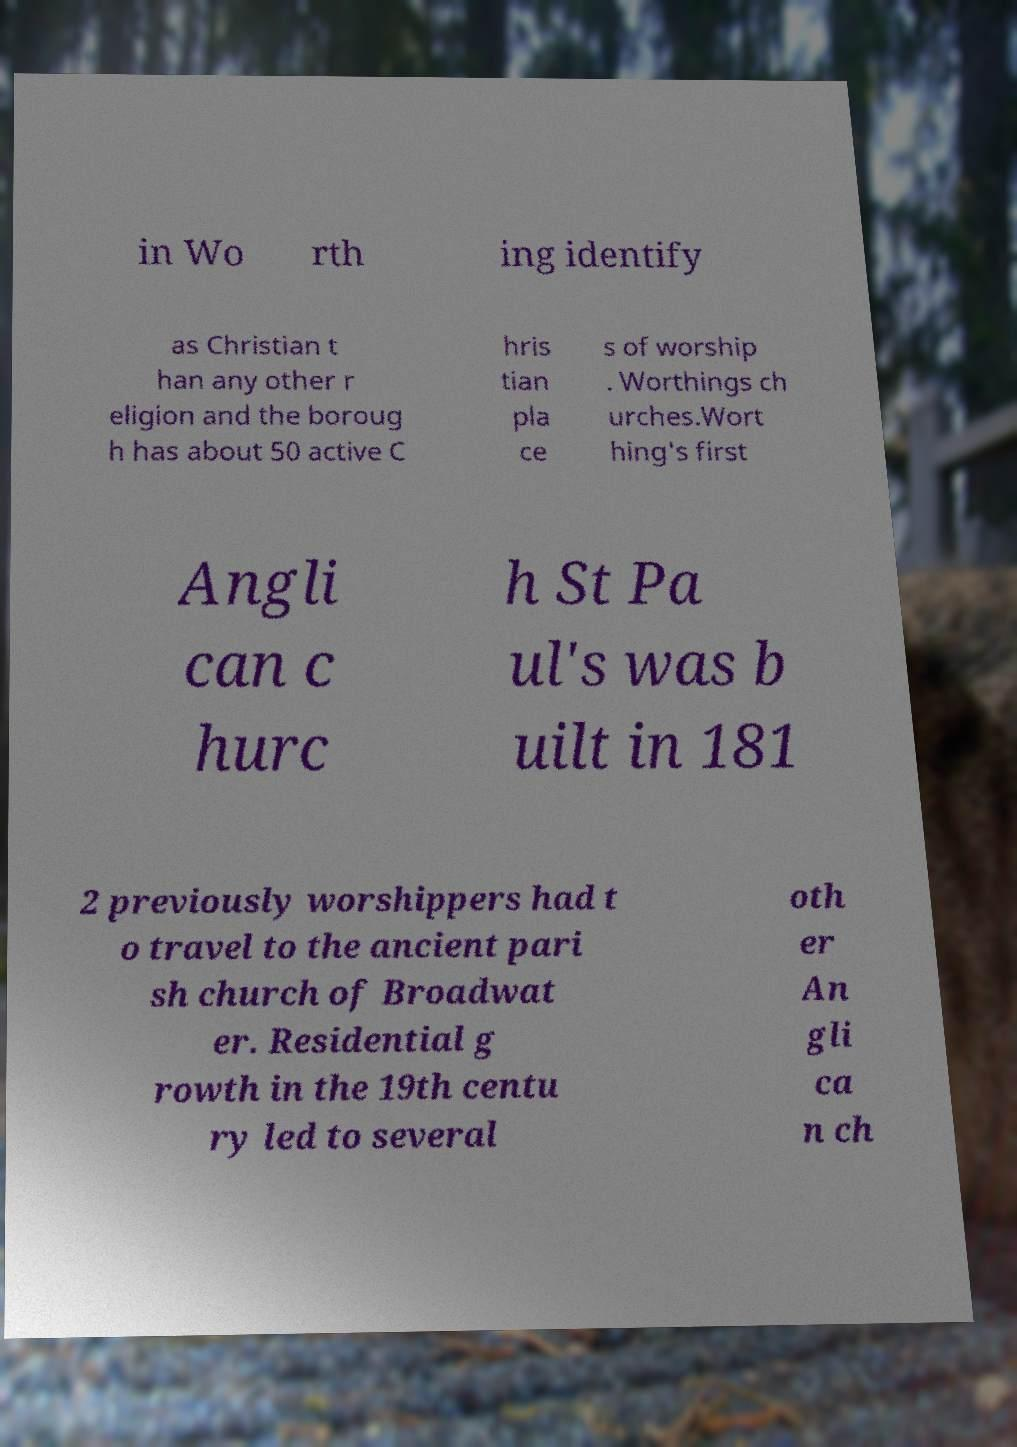Could you extract and type out the text from this image? in Wo rth ing identify as Christian t han any other r eligion and the boroug h has about 50 active C hris tian pla ce s of worship . Worthings ch urches.Wort hing's first Angli can c hurc h St Pa ul's was b uilt in 181 2 previously worshippers had t o travel to the ancient pari sh church of Broadwat er. Residential g rowth in the 19th centu ry led to several oth er An gli ca n ch 